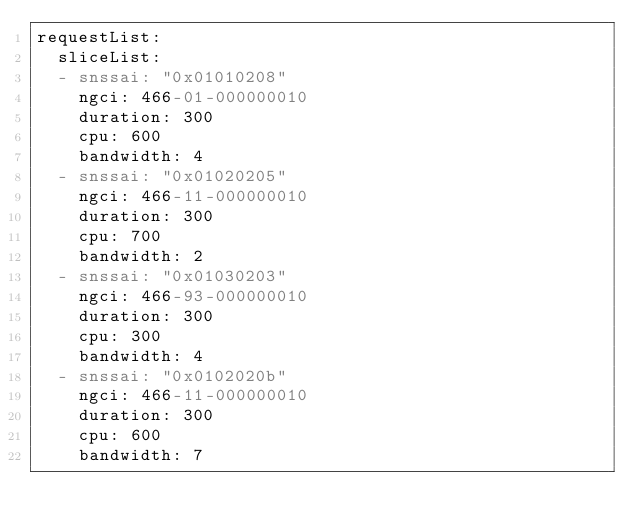<code> <loc_0><loc_0><loc_500><loc_500><_YAML_>requestList:
  sliceList:
  - snssai: "0x01010208"
    ngci: 466-01-000000010
    duration: 300
    cpu: 600
    bandwidth: 4
  - snssai: "0x01020205"
    ngci: 466-11-000000010
    duration: 300
    cpu: 700
    bandwidth: 2
  - snssai: "0x01030203"
    ngci: 466-93-000000010
    duration: 300
    cpu: 300
    bandwidth: 4
  - snssai: "0x0102020b"
    ngci: 466-11-000000010
    duration: 300
    cpu: 600
    bandwidth: 7
</code> 